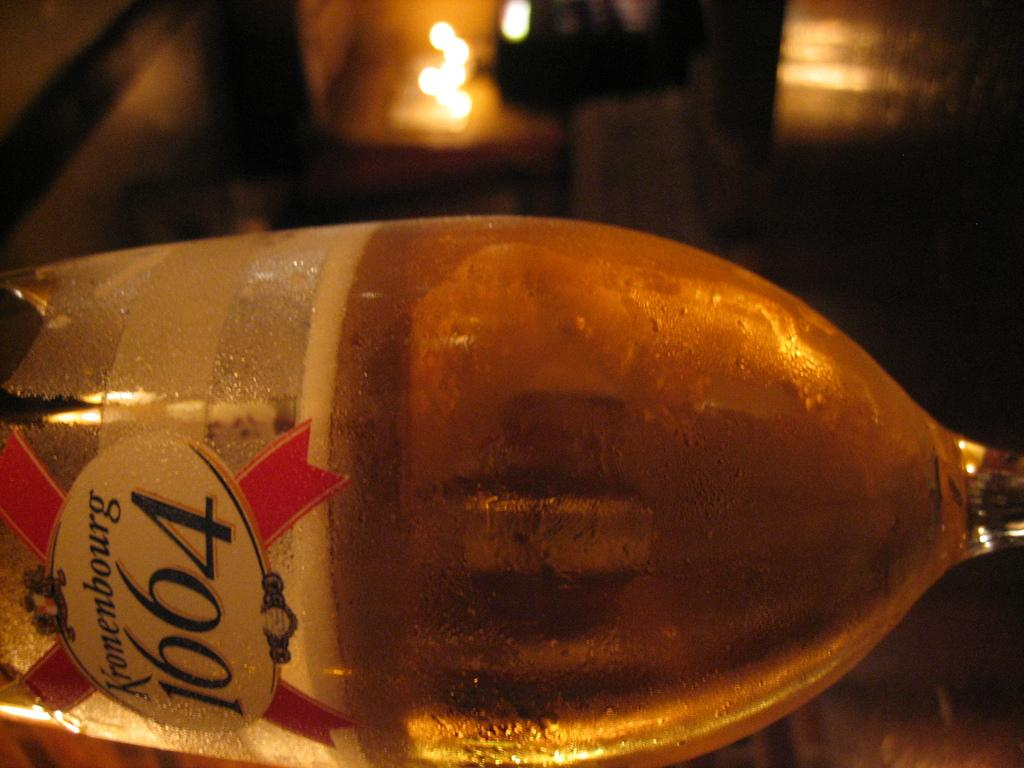<image>
Render a clear and concise summary of the photo. A Bottle of Kronenbourg 1664 lying on the table. 